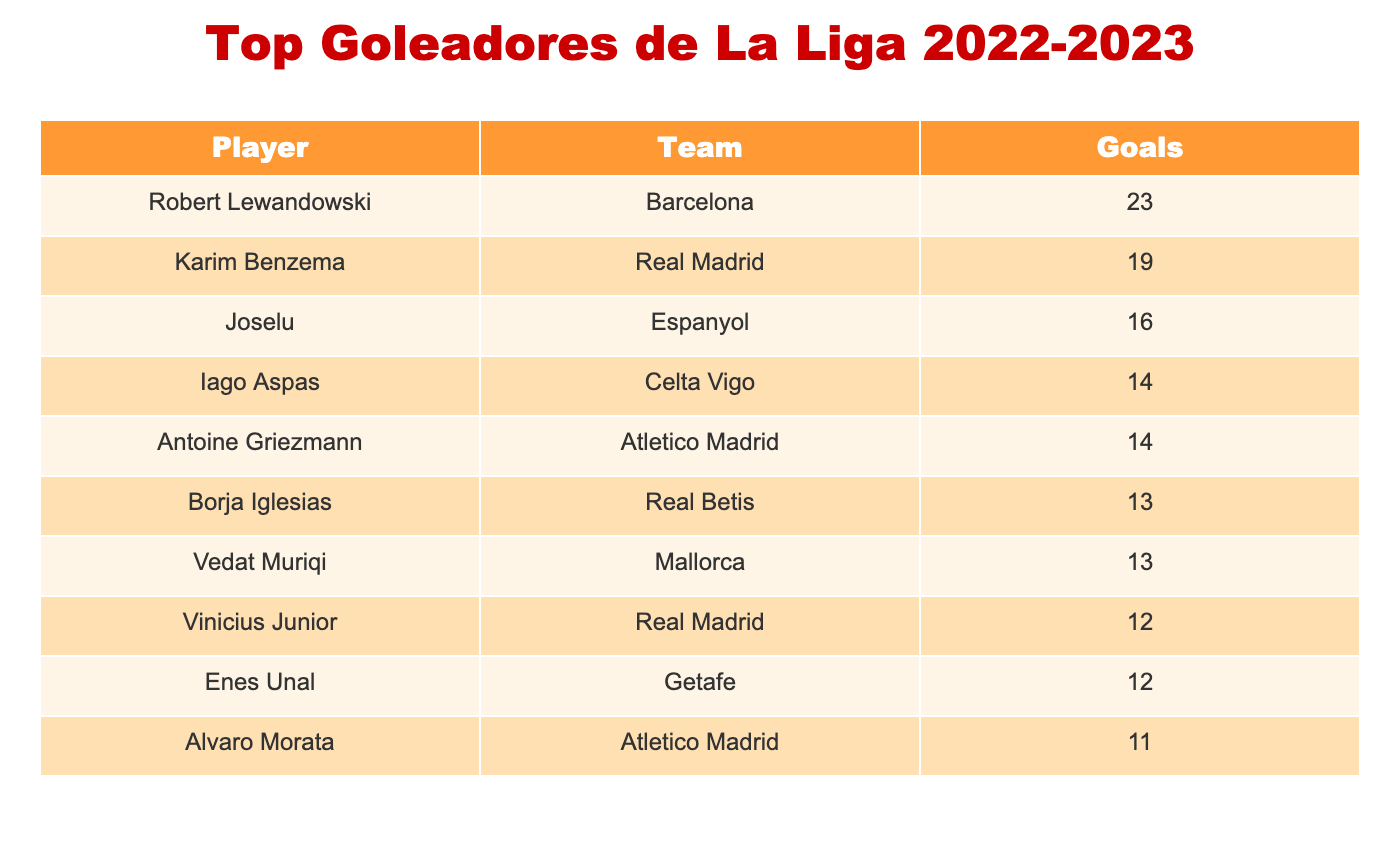What is the total number of goals scored by the top three players? To find the total number of goals scored by the top three players, we look at their goals: Robert Lewandowski (23), Karim Benzema (19), and Joselu (16). We add these together: 23 + 19 + 16 = 58.
Answer: 58 Who scored more goals, Iago Aspas or Antoine Griezmann? Iago Aspas scored 14 goals, while Antoine Griezmann also scored 14 goals. Since both players scored the same amount, it means neither scored more goals than the other.
Answer: Neither What is the average number of goals among the players listed? To calculate the average, we need to sum all the goals: 23 + 19 + 16 + 14 + 14 + 13 + 13 + 12 + 12 + 11 =  153. There are 10 players, so we divide 153 by 10, which gives us an average of 15.3.
Answer: 15.3 Is Borja Iglesias among the top five goal scorers? We can see from the table that the top five goal scorers are Robert Lewandowski, Karim Benzema, Joselu, Iago Aspas, and Antoine Griezmann. Borja Iglesias is in sixth place with 13 goals. Therefore, he is not among the top five.
Answer: No How many players scored 12 goals? Looking at the table, we find that both Vinicius Junior and Enes Unal scored 12 goals. So, there are 2 players who scored this amount.
Answer: 2 What is the difference in goals scored between the highest and lowest goal scorer? The highest goal scorer is Robert Lewandowski with 23 goals, and the lowest one listed is Alvaro Morata with 11 goals. To find the difference, we subtract: 23 - 11 = 12.
Answer: 12 Which player from Real Madrid scored the most goals? Looking at the table, we see that both Karim Benzema and Vinicius Junior are from Real Madrid. Benzema scored 19 goals, while Vinicius Junior scored 12. Therefore, Karim Benzema is the player from Real Madrid who scored the most goals.
Answer: Karim Benzema Are there any players who scored the same number of goals? Yes, Joselu, Iago Aspas, and Antoine Griezmann all scored 14 goals, while both Borja Iglesias and Vedat Muriqi each scored 13 goals. So, there are several instances of players scoring the same amount.
Answer: Yes 